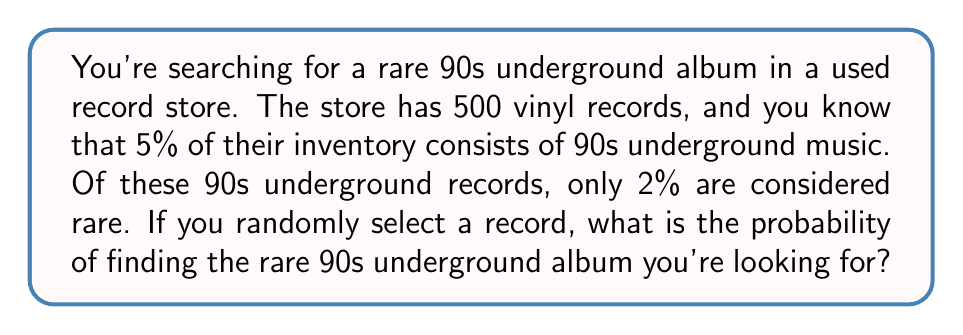Can you solve this math problem? Let's approach this step-by-step:

1. Calculate the number of 90s underground records:
   $500 \times 5\% = 500 \times 0.05 = 25$ records

2. Calculate the number of rare 90s underground records:
   $25 \times 2\% = 25 \times 0.02 = 0.5$ records

3. The probability is the number of favorable outcomes divided by the total number of possible outcomes:

   $$P(\text{rare 90s underground album}) = \frac{\text{number of rare 90s underground records}}{\text{total number of records}}$$

   $$P(\text{rare 90s underground album}) = \frac{0.5}{500} = \frac{1}{1000} = 0.001$$

4. Convert to a percentage:
   $0.001 \times 100\% = 0.1\%$

Therefore, the probability of randomly selecting the rare 90s underground album is 0.1% or 1 in 1000.
Answer: $0.1\%$ or $\frac{1}{1000}$ 